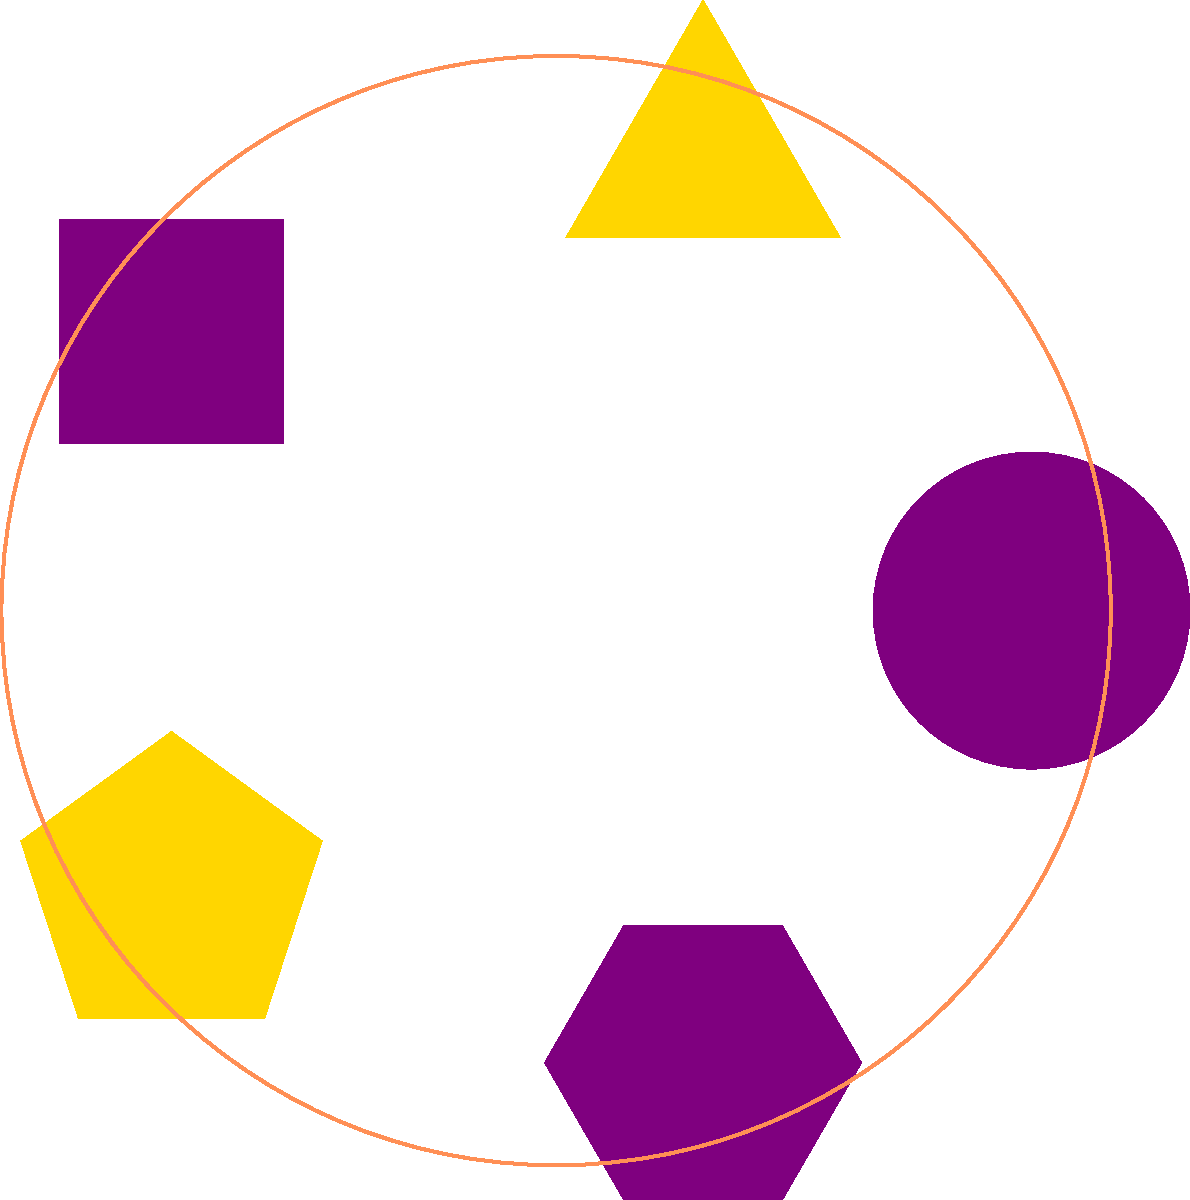In the pattern above, which shape comes next in the sequence, following the established order and color scheme? To solve this problem, let's analyze the pattern step-by-step:

1. Shape sequence:
   - Circle
   - Triangle
   - Square
   - Pentagon
   - Hexagon

2. Color sequence:
   - Purple
   - Gold
   - Purple
   - Gold
   - Purple

3. Pattern observations:
   - The shapes increase in the number of sides, starting from a circle (infinite sides) to a hexagon (6 sides).
   - The colors alternate between purple and gold.

4. Next in the sequence:
   - The next shape would have 7 sides, which is a heptagon.
   - Following the color pattern, it would be gold.

Therefore, the next shape in the sequence would be a gold heptagon.
Answer: Gold heptagon 